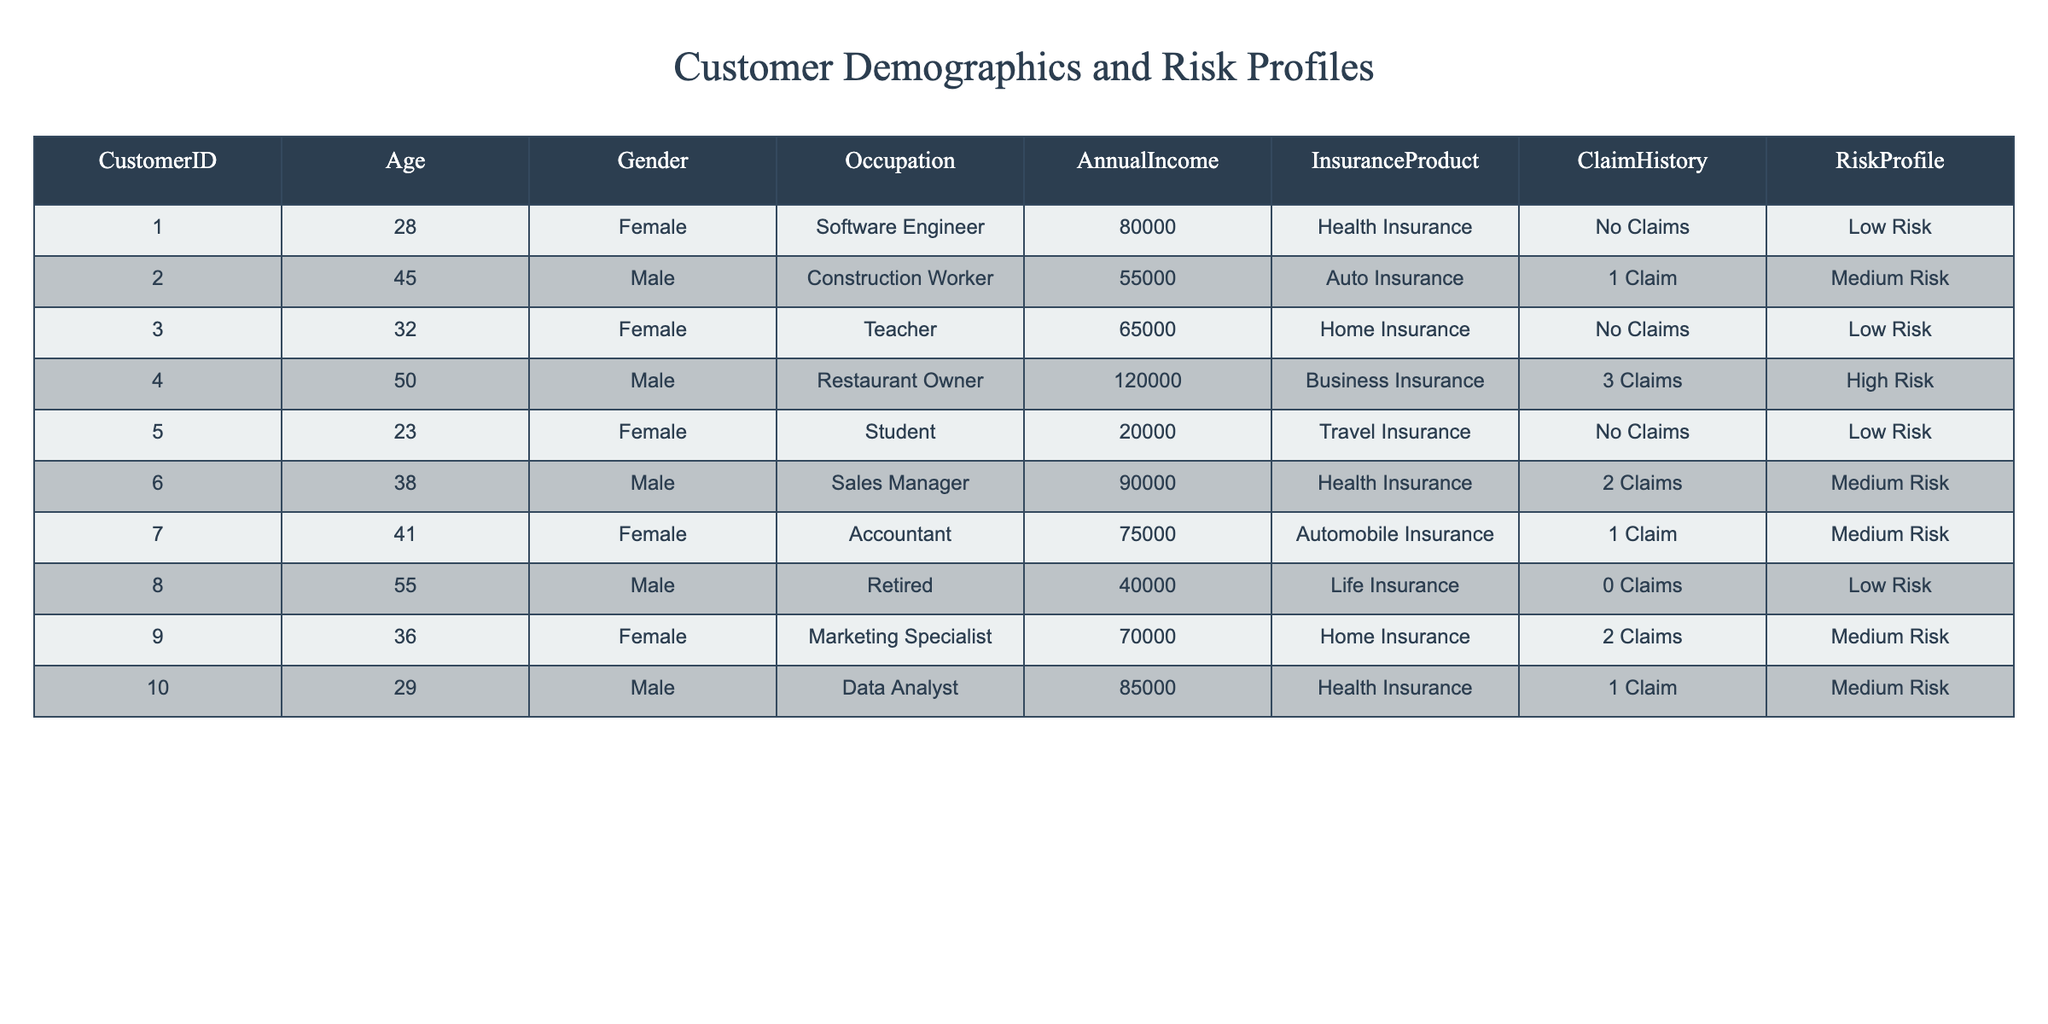What is the age of the customer who has the highest risk profile? The customer with the highest risk profile is the Restaurant Owner, who is 50 years old. This is directly observable in the table under the Age column when looking at the Risk Profile in conjunction with the respective customer profiles.
Answer: 50 How many customers have a Medium Risk profile? There are 4 customers with a Medium Risk profile: the Construction Worker, Sales Manager, Accountant, and Marketing Specialist. Counting these rows in the Risk Profile column confirms this.
Answer: 4 What is the average annual income of customers with Low Risk? The Low Risk customers are the Software Engineer, Teacher, Student, and Retired. Their annual incomes are 80000, 65000, 20000, and 40000 respectively. The total annual income is 80000 + 65000 + 20000 + 40000 = 205000. There are 4 Low Risk customers, so the average is 205000 / 4 = 51250.
Answer: 51250 Is there a customer who has made claims and also has a High Risk profile? Yes, the customer with the highest risk profile, the Restaurant Owner, has made 3 claims. This is verified by checking the Claim History and Risk Profile columns for the respective customer.
Answer: Yes Among customers with Health Insurance, how many have made claims? There are 3 customers with Health Insurance: the Software Engineer (No Claims), the Sales Manager (2 Claims), and the Data Analyst (1 Claim). Only the Sales Manager and Data Analyst have made claims, totaling 2 customers. This is determined by filtering the table based on the Insurance Product and checking the Claim History.
Answer: 2 What is the occupation of the customer with the lowest risk profile? The customer with the lowest risk profile is the Software Engineer. This conclusion is reached by identifying the Risk Profile of customers in the table and correlating it with their Occupation.
Answer: Software Engineer How many claims did the customer with the second-highest annual income make? The customer with the second-highest annual income is the Sales Manager, who earns 90000. Referring to the Claim History column, the Sales Manager has made 2 claims. Thus, we identify the customer based on income and then reference their claims.
Answer: 2 Which gender has a higher representation among customers with High Risk profiles? Among customers with High Risk profiles, there is 1 Male (Restaurant Owner) and 0 Females. Therefore, the Male gender has a higher representation, as verified by examining the respective gender counts.
Answer: Male 